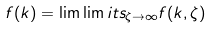Convert formula to latex. <formula><loc_0><loc_0><loc_500><loc_500>f ( k ) = \lim \lim i t s _ { \zeta \to \infty } f ( k , \zeta )</formula> 